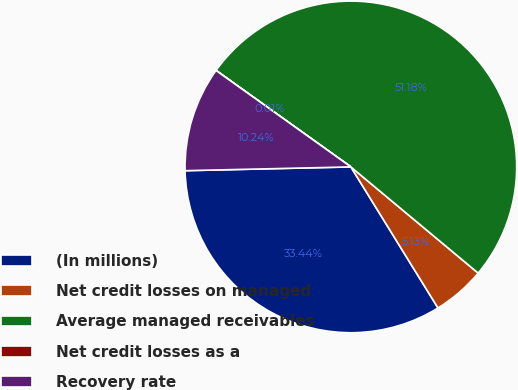Convert chart. <chart><loc_0><loc_0><loc_500><loc_500><pie_chart><fcel>(In millions)<fcel>Net credit losses on managed<fcel>Average managed receivables<fcel>Net credit losses as a<fcel>Recovery rate<nl><fcel>33.44%<fcel>5.13%<fcel>51.17%<fcel>0.01%<fcel>10.24%<nl></chart> 